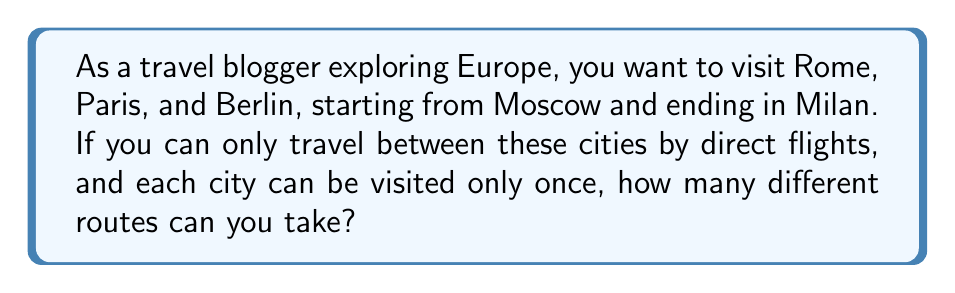What is the answer to this math problem? Let's approach this step-by-step:

1) We start in Moscow and end in Milan, so these cities are fixed in our route.

2) We need to arrange the other three cities (Rome, Paris, and Berlin) in between.

3) This is a permutation problem. We're arranging 3 cities in 3 spots.

4) The number of permutations of $n$ distinct objects is given by $n!$

5) In this case, $n = 3$, so we calculate $3!$:

   $$3! = 3 \times 2 \times 1 = 6$$

6) Therefore, there are 6 possible arrangements of Rome, Paris, and Berlin.

7) Each arrangement represents a unique route from Moscow to Milan, passing through these three cities.

Thus, there are 6 different possible routes.
Answer: 6 routes 